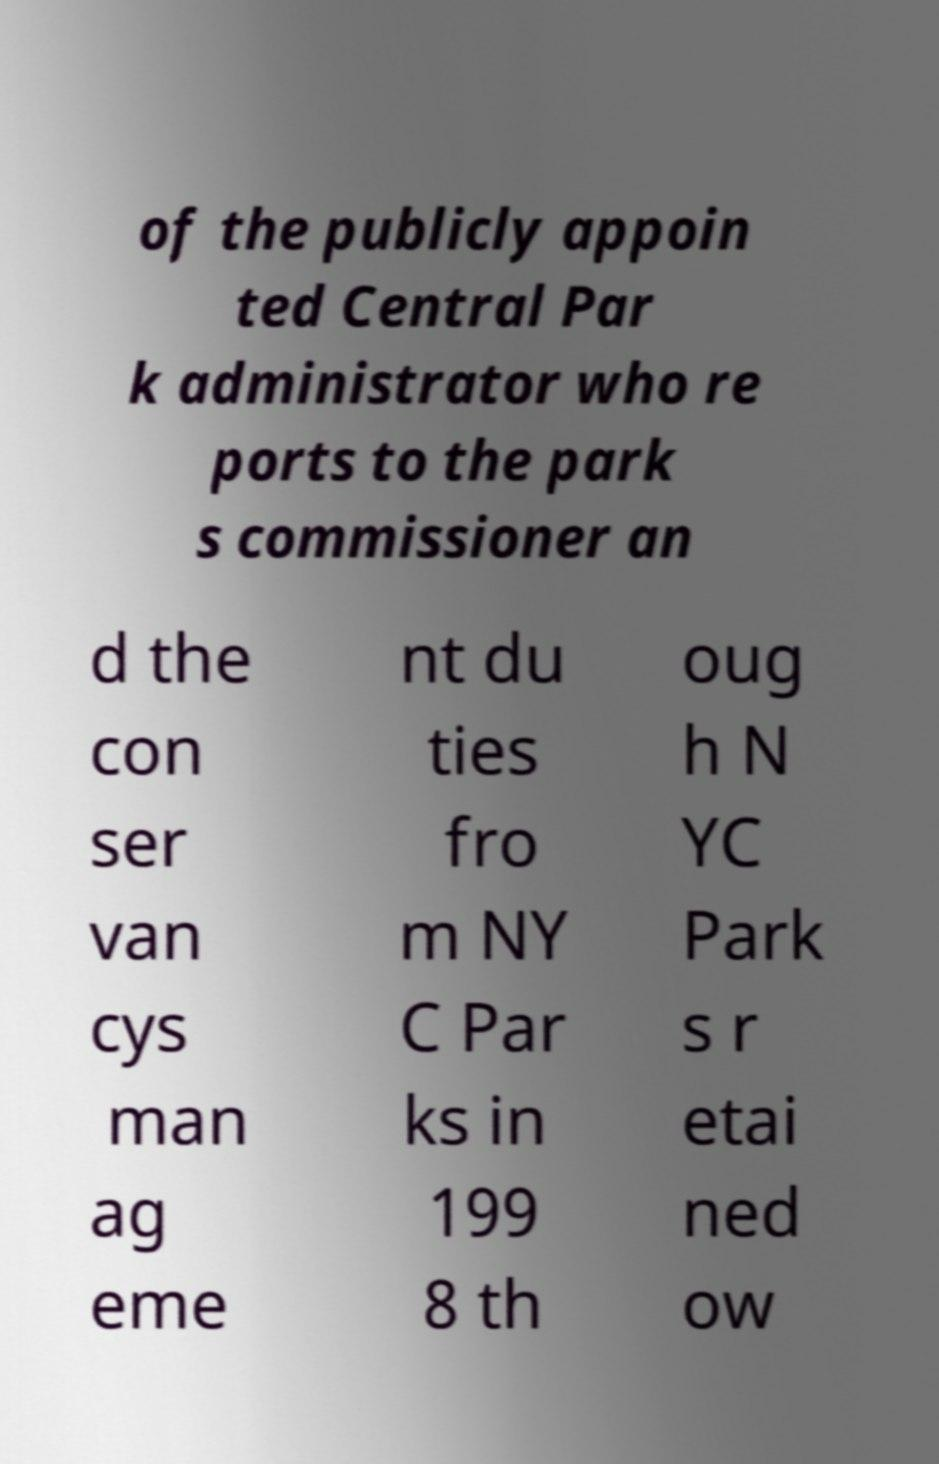Could you extract and type out the text from this image? of the publicly appoin ted Central Par k administrator who re ports to the park s commissioner an d the con ser van cys man ag eme nt du ties fro m NY C Par ks in 199 8 th oug h N YC Park s r etai ned ow 